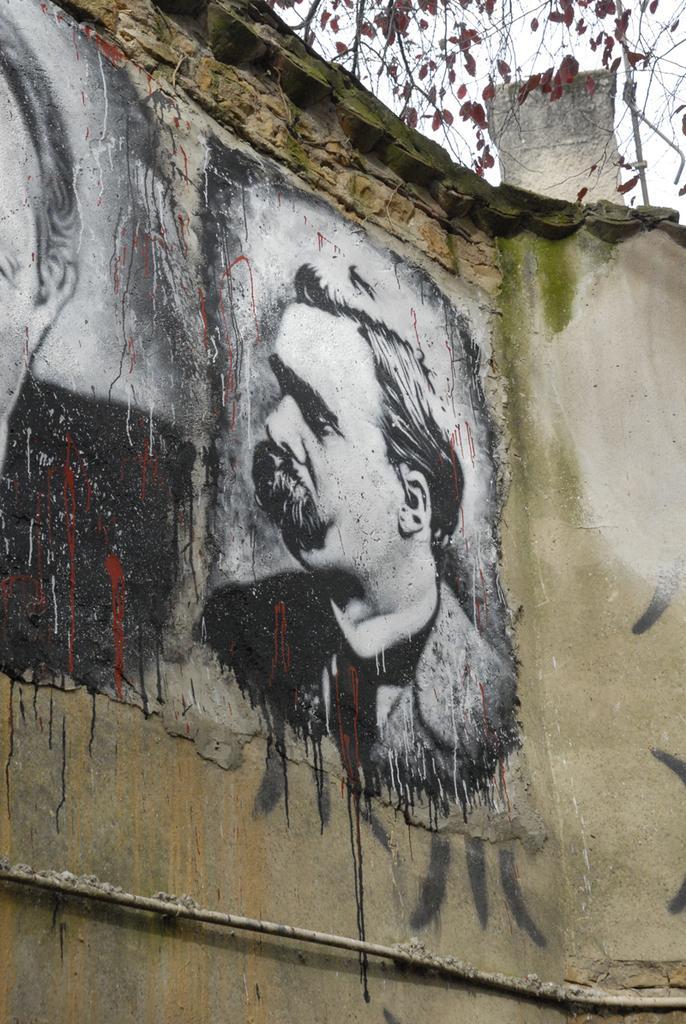Can you describe this image briefly? This picture is clicked outside. In the foreground we can see the wall of a house and we can see the depictions of two people on the wall. At the top we can see the sky, leaves and some objects. At the bottom there is an object which seems to be the metal rod. 